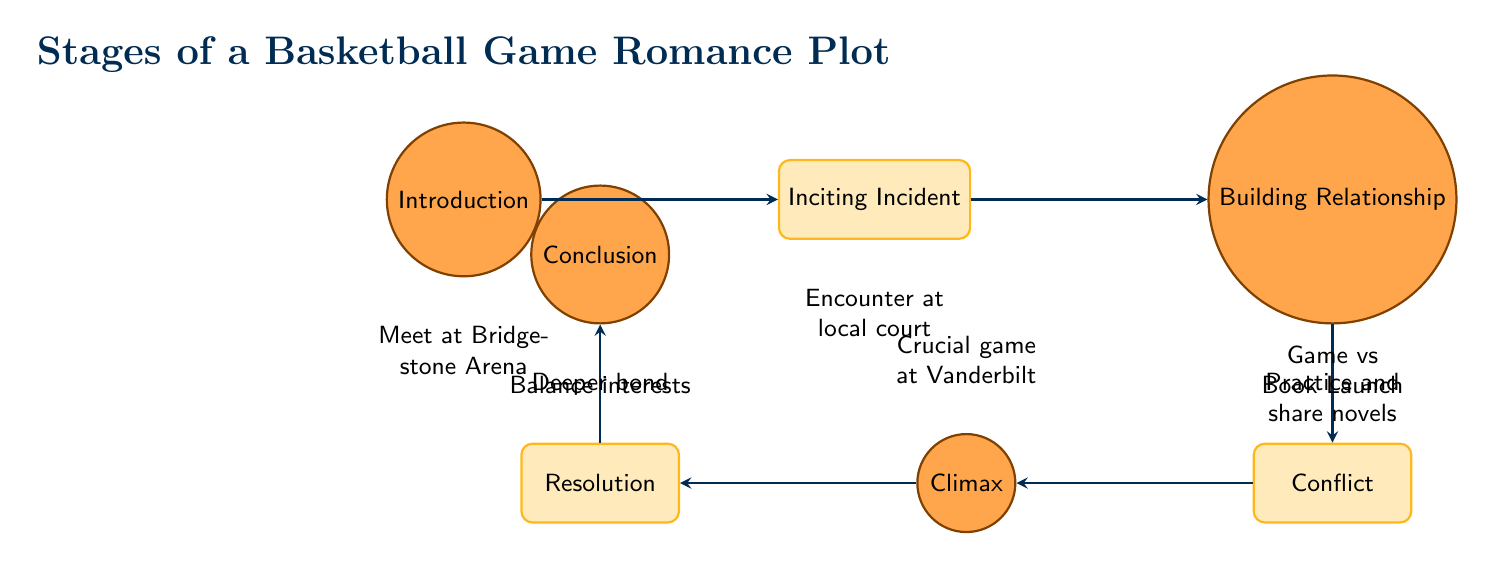What is the first stage of the plot? The diagram shows "Introduction" as the first node, which represents the starting point of the romance plot.
Answer: Introduction How many nodes are in the diagram? By counting each unique stage in the flow chart, we find there are seven stages total.
Answer: 7 What stage comes after "Building Relationship"? The flow indicates that "Conflict" is the immediate next stage after "Building Relationship."
Answer: Conflict What is the climax of the plot? The climax node is labeled as "Climax," which indicates the peak moment in the romance narrative.
Answer: Climax What dilemma do the protagonists face? The conflict node describes a overlapping schedule between games and a book launch, indicating the conflicting priorities they must address.
Answer: Game vs Book Launch What is the key event at Vanderbilt University? The climax describes a "Crucial game at Vanderbilt University," which signifies the important event taking place at this location.
Answer: Crucial game at Vanderbilt University What do the protagonists do after the game? The resolution node describes that they "attend the book launch together," signifying their decision to support each other after facing prior conflicts.
Answer: Attend the book launch together What stage emphasizes the growth of the protagonists' bond? The last stage "Conclusion" emphasizes the deepened bond and continued growth of the protagonists.
Answer: Conclusion What is the primary setting where the protagonists meet first? The introduction node states they meet at "Bridgestone Arena," specifying the location where their story begins.
Answer: Bridgestone Arena 